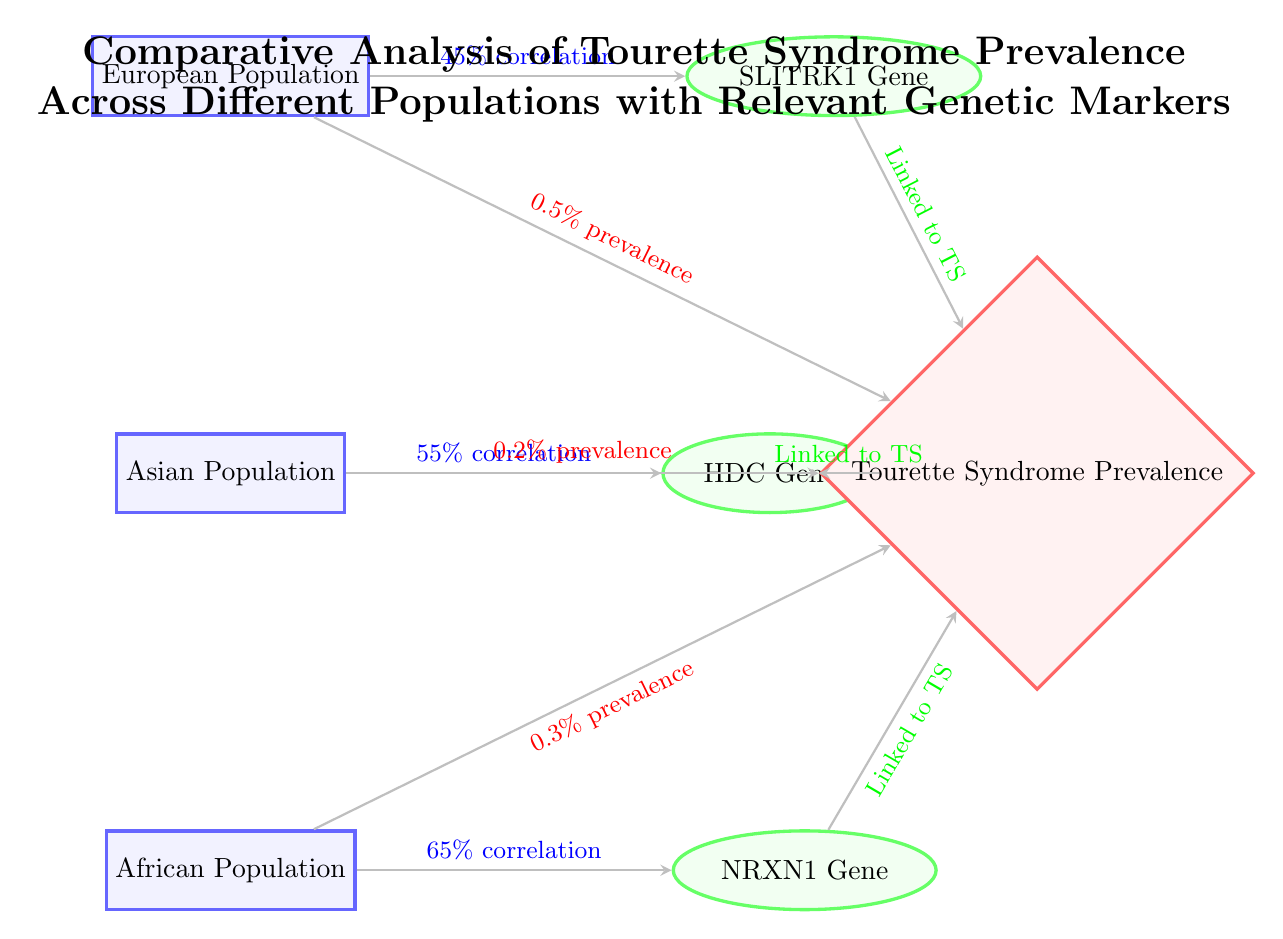What is the prevalence of Tourette Syndrome in the European Population? The arrow pointing from the European Population node to the Tourette Syndrome Prevalence node indicates a prevalence of 0.5%.
Answer: 0.5% Which genetic marker is associated with the Asian Population? The arrow from the Asian Population node points to the HDC Gene node, indicating that this gene is relevant to this population.
Answer: HDC Gene What percentage correlation does the African Population have with the NRXN1 Gene? The arrow from the African Population node to the NRXN1 Gene node shows a correlation of 65%.
Answer: 65% How many populations are represented in this diagram? There are three population nodes: European, Asian, and African, thus counting them gives a total of three.
Answer: 3 Which population exhibits the lowest prevalence of Tourette Syndrome? The arrow from the Asian Population to the Tourette Syndrome Prevalence node shows a prevalence of 0.2%, which is lower than the other populations.
Answer: Asian Population What is the total percentage correlation for the European Population? The diagram shows that the correlation from the European Population to the SLITRK1 Gene is 45%. There is no need to sum different correlations, as the question is about this specific population's correlation result.
Answer: 45% Which gene is linked to all populations in the diagram? All populations (European, Asian, and African) have arrows pointing to the Tourette Syndrome Prevalence node with the label "Linked to TS," which indicates each gene is linked to Tourette Syndrome.
Answer: All genes What is the relationship between the African Population and the SLITRK1 Gene? The African Population does not have a direct relationship with the SLITRK1 Gene since it points only to the NRXN1 Gene. Thus, no correlation is established.
Answer: None 